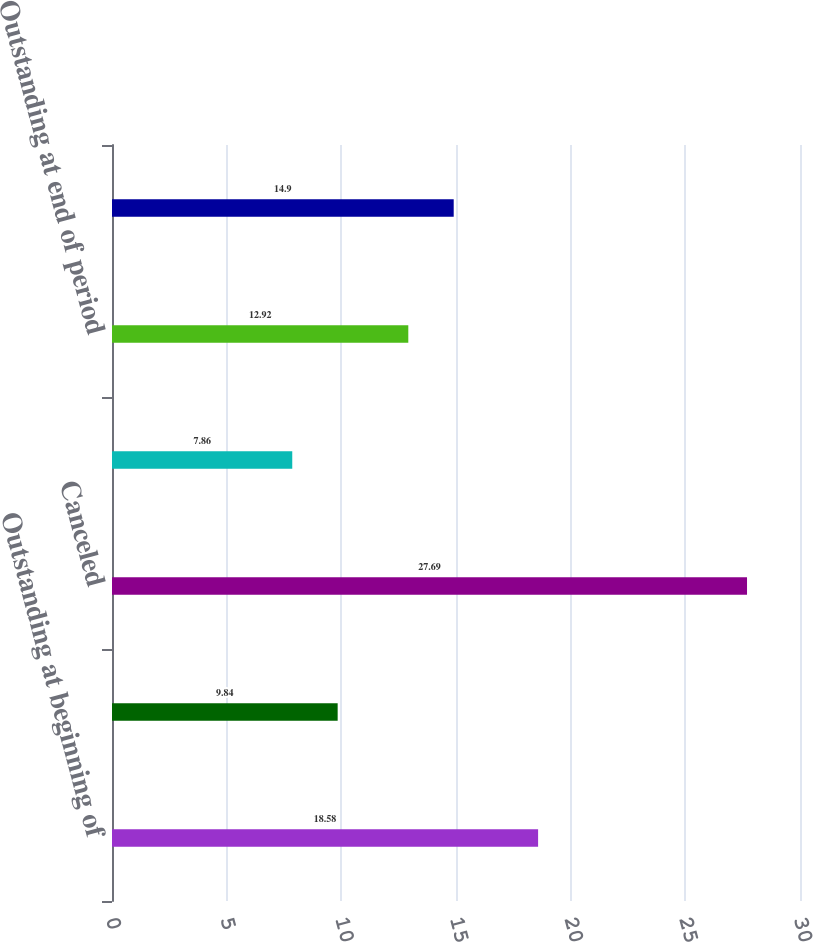Convert chart. <chart><loc_0><loc_0><loc_500><loc_500><bar_chart><fcel>Outstanding at beginning of<fcel>Granted<fcel>Canceled<fcel>Exercised<fcel>Outstanding at end of period<fcel>Exercisable at end of period<nl><fcel>18.58<fcel>9.84<fcel>27.69<fcel>7.86<fcel>12.92<fcel>14.9<nl></chart> 